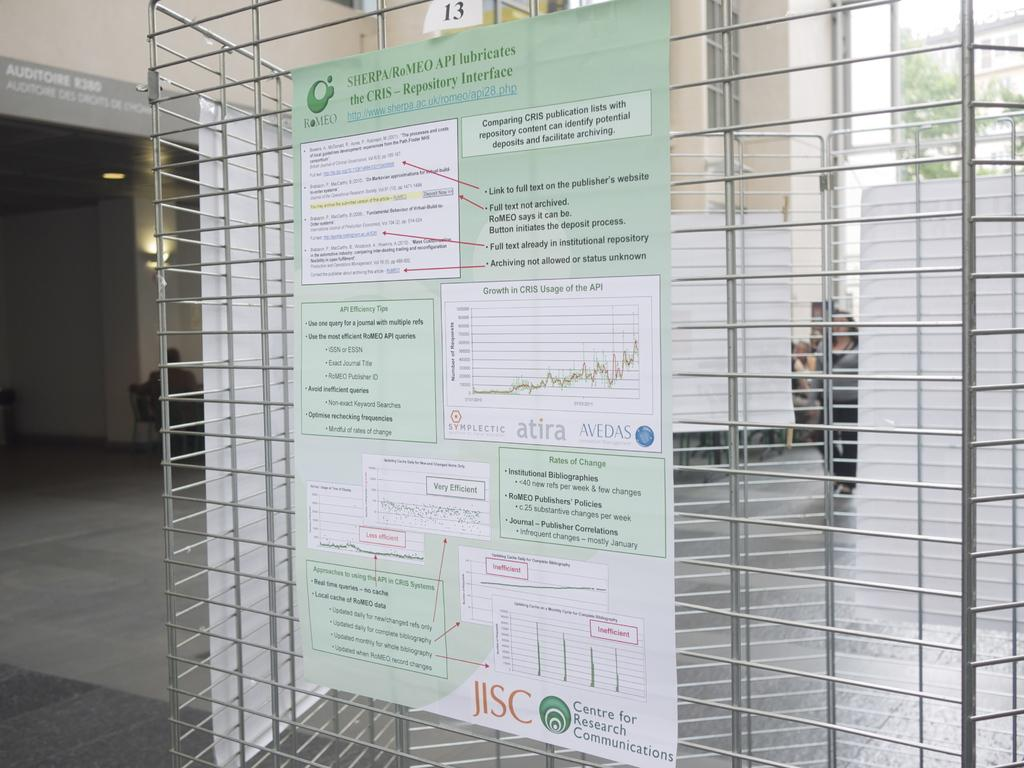<image>
Summarize the visual content of the image. Graphs appear on a poster with the JISC logo. 